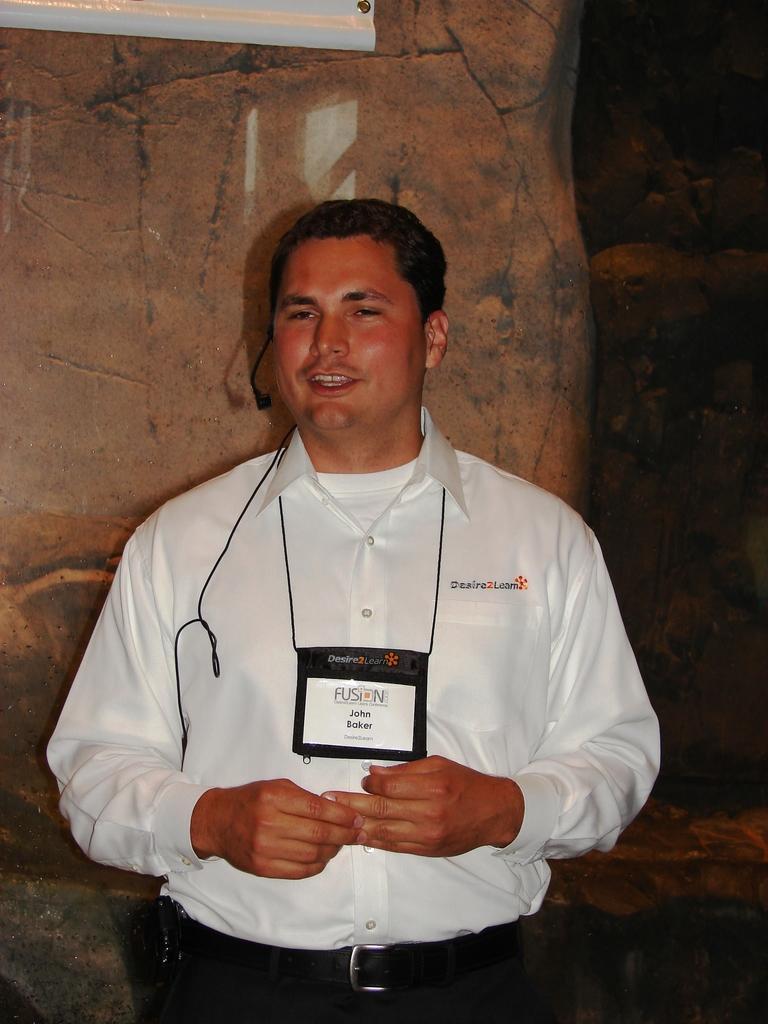In one or two sentences, can you explain what this image depicts? In this image we can see a man and there is a tag on his neck. In the background we can see rocks and an object at the top. 